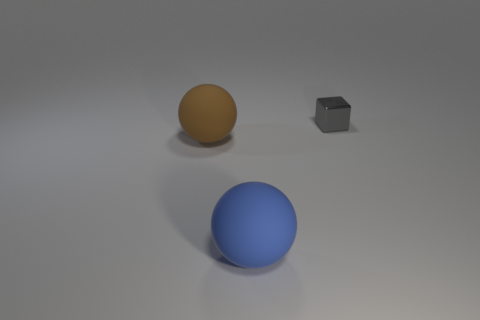Subtract all yellow balls. Subtract all gray blocks. How many balls are left? 2 Add 2 matte balls. How many objects exist? 5 Subtract all spheres. How many objects are left? 1 Subtract 0 cyan cylinders. How many objects are left? 3 Subtract all tiny gray objects. Subtract all tiny cyan balls. How many objects are left? 2 Add 2 brown matte objects. How many brown matte objects are left? 3 Add 2 yellow matte cubes. How many yellow matte cubes exist? 2 